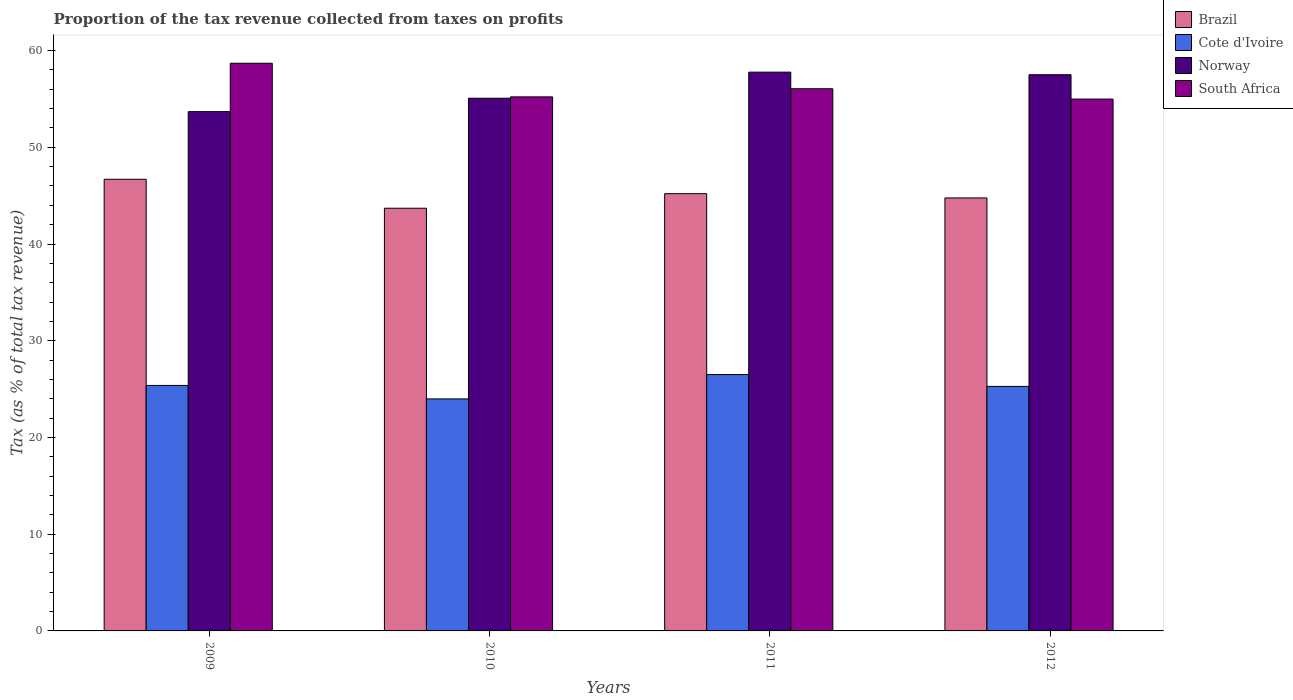How many groups of bars are there?
Provide a short and direct response. 4. Are the number of bars per tick equal to the number of legend labels?
Offer a terse response. Yes. How many bars are there on the 3rd tick from the left?
Offer a very short reply. 4. How many bars are there on the 3rd tick from the right?
Provide a succinct answer. 4. What is the proportion of the tax revenue collected in Norway in 2012?
Offer a terse response. 57.5. Across all years, what is the maximum proportion of the tax revenue collected in Cote d'Ivoire?
Provide a short and direct response. 26.5. Across all years, what is the minimum proportion of the tax revenue collected in Norway?
Ensure brevity in your answer.  53.69. In which year was the proportion of the tax revenue collected in Cote d'Ivoire minimum?
Keep it short and to the point. 2010. What is the total proportion of the tax revenue collected in Norway in the graph?
Give a very brief answer. 224.03. What is the difference between the proportion of the tax revenue collected in South Africa in 2010 and that in 2011?
Make the answer very short. -0.84. What is the difference between the proportion of the tax revenue collected in Brazil in 2010 and the proportion of the tax revenue collected in Norway in 2009?
Your answer should be compact. -9.99. What is the average proportion of the tax revenue collected in Norway per year?
Your response must be concise. 56.01. In the year 2012, what is the difference between the proportion of the tax revenue collected in Brazil and proportion of the tax revenue collected in Cote d'Ivoire?
Offer a terse response. 19.48. In how many years, is the proportion of the tax revenue collected in Brazil greater than 2 %?
Your answer should be compact. 4. What is the ratio of the proportion of the tax revenue collected in Brazil in 2011 to that in 2012?
Your answer should be compact. 1.01. Is the proportion of the tax revenue collected in South Africa in 2010 less than that in 2012?
Offer a very short reply. No. Is the difference between the proportion of the tax revenue collected in Brazil in 2010 and 2012 greater than the difference between the proportion of the tax revenue collected in Cote d'Ivoire in 2010 and 2012?
Give a very brief answer. Yes. What is the difference between the highest and the second highest proportion of the tax revenue collected in South Africa?
Provide a short and direct response. 2.63. What is the difference between the highest and the lowest proportion of the tax revenue collected in South Africa?
Give a very brief answer. 3.7. Is the sum of the proportion of the tax revenue collected in Cote d'Ivoire in 2011 and 2012 greater than the maximum proportion of the tax revenue collected in Brazil across all years?
Make the answer very short. Yes. What does the 2nd bar from the left in 2011 represents?
Offer a terse response. Cote d'Ivoire. What does the 3rd bar from the right in 2012 represents?
Your answer should be very brief. Cote d'Ivoire. Is it the case that in every year, the sum of the proportion of the tax revenue collected in South Africa and proportion of the tax revenue collected in Cote d'Ivoire is greater than the proportion of the tax revenue collected in Norway?
Give a very brief answer. Yes. How many years are there in the graph?
Provide a short and direct response. 4. Does the graph contain any zero values?
Provide a short and direct response. No. What is the title of the graph?
Give a very brief answer. Proportion of the tax revenue collected from taxes on profits. What is the label or title of the X-axis?
Your answer should be compact. Years. What is the label or title of the Y-axis?
Ensure brevity in your answer.  Tax (as % of total tax revenue). What is the Tax (as % of total tax revenue) of Brazil in 2009?
Offer a terse response. 46.69. What is the Tax (as % of total tax revenue) in Cote d'Ivoire in 2009?
Provide a short and direct response. 25.38. What is the Tax (as % of total tax revenue) of Norway in 2009?
Offer a very short reply. 53.69. What is the Tax (as % of total tax revenue) of South Africa in 2009?
Give a very brief answer. 58.69. What is the Tax (as % of total tax revenue) of Brazil in 2010?
Your answer should be very brief. 43.7. What is the Tax (as % of total tax revenue) of Cote d'Ivoire in 2010?
Your answer should be very brief. 23.99. What is the Tax (as % of total tax revenue) in Norway in 2010?
Keep it short and to the point. 55.07. What is the Tax (as % of total tax revenue) of South Africa in 2010?
Give a very brief answer. 55.21. What is the Tax (as % of total tax revenue) in Brazil in 2011?
Offer a very short reply. 45.21. What is the Tax (as % of total tax revenue) in Cote d'Ivoire in 2011?
Give a very brief answer. 26.5. What is the Tax (as % of total tax revenue) in Norway in 2011?
Offer a very short reply. 57.77. What is the Tax (as % of total tax revenue) of South Africa in 2011?
Your answer should be very brief. 56.05. What is the Tax (as % of total tax revenue) of Brazil in 2012?
Your answer should be compact. 44.76. What is the Tax (as % of total tax revenue) of Cote d'Ivoire in 2012?
Offer a terse response. 25.28. What is the Tax (as % of total tax revenue) of Norway in 2012?
Keep it short and to the point. 57.5. What is the Tax (as % of total tax revenue) in South Africa in 2012?
Ensure brevity in your answer.  54.98. Across all years, what is the maximum Tax (as % of total tax revenue) of Brazil?
Offer a terse response. 46.69. Across all years, what is the maximum Tax (as % of total tax revenue) in Cote d'Ivoire?
Your answer should be very brief. 26.5. Across all years, what is the maximum Tax (as % of total tax revenue) in Norway?
Offer a terse response. 57.77. Across all years, what is the maximum Tax (as % of total tax revenue) in South Africa?
Give a very brief answer. 58.69. Across all years, what is the minimum Tax (as % of total tax revenue) of Brazil?
Your answer should be very brief. 43.7. Across all years, what is the minimum Tax (as % of total tax revenue) in Cote d'Ivoire?
Provide a short and direct response. 23.99. Across all years, what is the minimum Tax (as % of total tax revenue) of Norway?
Your answer should be very brief. 53.69. Across all years, what is the minimum Tax (as % of total tax revenue) in South Africa?
Your answer should be compact. 54.98. What is the total Tax (as % of total tax revenue) of Brazil in the graph?
Keep it short and to the point. 180.36. What is the total Tax (as % of total tax revenue) of Cote d'Ivoire in the graph?
Your answer should be compact. 101.15. What is the total Tax (as % of total tax revenue) of Norway in the graph?
Your answer should be very brief. 224.03. What is the total Tax (as % of total tax revenue) in South Africa in the graph?
Ensure brevity in your answer.  224.94. What is the difference between the Tax (as % of total tax revenue) in Brazil in 2009 and that in 2010?
Make the answer very short. 2.99. What is the difference between the Tax (as % of total tax revenue) of Cote d'Ivoire in 2009 and that in 2010?
Give a very brief answer. 1.39. What is the difference between the Tax (as % of total tax revenue) of Norway in 2009 and that in 2010?
Make the answer very short. -1.39. What is the difference between the Tax (as % of total tax revenue) of South Africa in 2009 and that in 2010?
Keep it short and to the point. 3.47. What is the difference between the Tax (as % of total tax revenue) in Brazil in 2009 and that in 2011?
Your response must be concise. 1.49. What is the difference between the Tax (as % of total tax revenue) of Cote d'Ivoire in 2009 and that in 2011?
Offer a very short reply. -1.12. What is the difference between the Tax (as % of total tax revenue) of Norway in 2009 and that in 2011?
Your answer should be very brief. -4.08. What is the difference between the Tax (as % of total tax revenue) in South Africa in 2009 and that in 2011?
Your response must be concise. 2.63. What is the difference between the Tax (as % of total tax revenue) in Brazil in 2009 and that in 2012?
Ensure brevity in your answer.  1.93. What is the difference between the Tax (as % of total tax revenue) in Cote d'Ivoire in 2009 and that in 2012?
Offer a terse response. 0.1. What is the difference between the Tax (as % of total tax revenue) in Norway in 2009 and that in 2012?
Your response must be concise. -3.82. What is the difference between the Tax (as % of total tax revenue) of South Africa in 2009 and that in 2012?
Offer a terse response. 3.7. What is the difference between the Tax (as % of total tax revenue) in Brazil in 2010 and that in 2011?
Offer a terse response. -1.51. What is the difference between the Tax (as % of total tax revenue) of Cote d'Ivoire in 2010 and that in 2011?
Ensure brevity in your answer.  -2.52. What is the difference between the Tax (as % of total tax revenue) of Norway in 2010 and that in 2011?
Offer a very short reply. -2.7. What is the difference between the Tax (as % of total tax revenue) of South Africa in 2010 and that in 2011?
Give a very brief answer. -0.84. What is the difference between the Tax (as % of total tax revenue) in Brazil in 2010 and that in 2012?
Offer a very short reply. -1.06. What is the difference between the Tax (as % of total tax revenue) in Cote d'Ivoire in 2010 and that in 2012?
Keep it short and to the point. -1.29. What is the difference between the Tax (as % of total tax revenue) in Norway in 2010 and that in 2012?
Provide a short and direct response. -2.43. What is the difference between the Tax (as % of total tax revenue) of South Africa in 2010 and that in 2012?
Make the answer very short. 0.23. What is the difference between the Tax (as % of total tax revenue) of Brazil in 2011 and that in 2012?
Offer a terse response. 0.44. What is the difference between the Tax (as % of total tax revenue) of Cote d'Ivoire in 2011 and that in 2012?
Keep it short and to the point. 1.23. What is the difference between the Tax (as % of total tax revenue) in Norway in 2011 and that in 2012?
Your answer should be very brief. 0.27. What is the difference between the Tax (as % of total tax revenue) of South Africa in 2011 and that in 2012?
Offer a very short reply. 1.07. What is the difference between the Tax (as % of total tax revenue) in Brazil in 2009 and the Tax (as % of total tax revenue) in Cote d'Ivoire in 2010?
Provide a short and direct response. 22.71. What is the difference between the Tax (as % of total tax revenue) of Brazil in 2009 and the Tax (as % of total tax revenue) of Norway in 2010?
Your answer should be compact. -8.38. What is the difference between the Tax (as % of total tax revenue) of Brazil in 2009 and the Tax (as % of total tax revenue) of South Africa in 2010?
Provide a succinct answer. -8.52. What is the difference between the Tax (as % of total tax revenue) of Cote d'Ivoire in 2009 and the Tax (as % of total tax revenue) of Norway in 2010?
Ensure brevity in your answer.  -29.69. What is the difference between the Tax (as % of total tax revenue) of Cote d'Ivoire in 2009 and the Tax (as % of total tax revenue) of South Africa in 2010?
Provide a short and direct response. -29.83. What is the difference between the Tax (as % of total tax revenue) in Norway in 2009 and the Tax (as % of total tax revenue) in South Africa in 2010?
Your answer should be compact. -1.53. What is the difference between the Tax (as % of total tax revenue) in Brazil in 2009 and the Tax (as % of total tax revenue) in Cote d'Ivoire in 2011?
Offer a very short reply. 20.19. What is the difference between the Tax (as % of total tax revenue) in Brazil in 2009 and the Tax (as % of total tax revenue) in Norway in 2011?
Ensure brevity in your answer.  -11.07. What is the difference between the Tax (as % of total tax revenue) in Brazil in 2009 and the Tax (as % of total tax revenue) in South Africa in 2011?
Make the answer very short. -9.36. What is the difference between the Tax (as % of total tax revenue) in Cote d'Ivoire in 2009 and the Tax (as % of total tax revenue) in Norway in 2011?
Give a very brief answer. -32.39. What is the difference between the Tax (as % of total tax revenue) in Cote d'Ivoire in 2009 and the Tax (as % of total tax revenue) in South Africa in 2011?
Provide a short and direct response. -30.67. What is the difference between the Tax (as % of total tax revenue) in Norway in 2009 and the Tax (as % of total tax revenue) in South Africa in 2011?
Give a very brief answer. -2.37. What is the difference between the Tax (as % of total tax revenue) in Brazil in 2009 and the Tax (as % of total tax revenue) in Cote d'Ivoire in 2012?
Keep it short and to the point. 21.42. What is the difference between the Tax (as % of total tax revenue) in Brazil in 2009 and the Tax (as % of total tax revenue) in Norway in 2012?
Your answer should be very brief. -10.81. What is the difference between the Tax (as % of total tax revenue) of Brazil in 2009 and the Tax (as % of total tax revenue) of South Africa in 2012?
Offer a very short reply. -8.29. What is the difference between the Tax (as % of total tax revenue) in Cote d'Ivoire in 2009 and the Tax (as % of total tax revenue) in Norway in 2012?
Make the answer very short. -32.12. What is the difference between the Tax (as % of total tax revenue) in Cote d'Ivoire in 2009 and the Tax (as % of total tax revenue) in South Africa in 2012?
Offer a very short reply. -29.61. What is the difference between the Tax (as % of total tax revenue) in Norway in 2009 and the Tax (as % of total tax revenue) in South Africa in 2012?
Offer a very short reply. -1.3. What is the difference between the Tax (as % of total tax revenue) of Brazil in 2010 and the Tax (as % of total tax revenue) of Cote d'Ivoire in 2011?
Provide a succinct answer. 17.2. What is the difference between the Tax (as % of total tax revenue) in Brazil in 2010 and the Tax (as % of total tax revenue) in Norway in 2011?
Give a very brief answer. -14.07. What is the difference between the Tax (as % of total tax revenue) of Brazil in 2010 and the Tax (as % of total tax revenue) of South Africa in 2011?
Provide a short and direct response. -12.35. What is the difference between the Tax (as % of total tax revenue) in Cote d'Ivoire in 2010 and the Tax (as % of total tax revenue) in Norway in 2011?
Provide a succinct answer. -33.78. What is the difference between the Tax (as % of total tax revenue) in Cote d'Ivoire in 2010 and the Tax (as % of total tax revenue) in South Africa in 2011?
Provide a succinct answer. -32.07. What is the difference between the Tax (as % of total tax revenue) in Norway in 2010 and the Tax (as % of total tax revenue) in South Africa in 2011?
Your response must be concise. -0.98. What is the difference between the Tax (as % of total tax revenue) of Brazil in 2010 and the Tax (as % of total tax revenue) of Cote d'Ivoire in 2012?
Offer a very short reply. 18.42. What is the difference between the Tax (as % of total tax revenue) of Brazil in 2010 and the Tax (as % of total tax revenue) of Norway in 2012?
Offer a very short reply. -13.8. What is the difference between the Tax (as % of total tax revenue) in Brazil in 2010 and the Tax (as % of total tax revenue) in South Africa in 2012?
Make the answer very short. -11.28. What is the difference between the Tax (as % of total tax revenue) in Cote d'Ivoire in 2010 and the Tax (as % of total tax revenue) in Norway in 2012?
Offer a terse response. -33.52. What is the difference between the Tax (as % of total tax revenue) in Cote d'Ivoire in 2010 and the Tax (as % of total tax revenue) in South Africa in 2012?
Make the answer very short. -31. What is the difference between the Tax (as % of total tax revenue) in Norway in 2010 and the Tax (as % of total tax revenue) in South Africa in 2012?
Keep it short and to the point. 0.09. What is the difference between the Tax (as % of total tax revenue) of Brazil in 2011 and the Tax (as % of total tax revenue) of Cote d'Ivoire in 2012?
Ensure brevity in your answer.  19.93. What is the difference between the Tax (as % of total tax revenue) of Brazil in 2011 and the Tax (as % of total tax revenue) of Norway in 2012?
Make the answer very short. -12.3. What is the difference between the Tax (as % of total tax revenue) of Brazil in 2011 and the Tax (as % of total tax revenue) of South Africa in 2012?
Ensure brevity in your answer.  -9.78. What is the difference between the Tax (as % of total tax revenue) of Cote d'Ivoire in 2011 and the Tax (as % of total tax revenue) of Norway in 2012?
Your answer should be very brief. -31. What is the difference between the Tax (as % of total tax revenue) in Cote d'Ivoire in 2011 and the Tax (as % of total tax revenue) in South Africa in 2012?
Offer a terse response. -28.48. What is the difference between the Tax (as % of total tax revenue) in Norway in 2011 and the Tax (as % of total tax revenue) in South Africa in 2012?
Keep it short and to the point. 2.78. What is the average Tax (as % of total tax revenue) in Brazil per year?
Your answer should be compact. 45.09. What is the average Tax (as % of total tax revenue) in Cote d'Ivoire per year?
Provide a succinct answer. 25.29. What is the average Tax (as % of total tax revenue) in Norway per year?
Your answer should be compact. 56.01. What is the average Tax (as % of total tax revenue) in South Africa per year?
Your answer should be compact. 56.23. In the year 2009, what is the difference between the Tax (as % of total tax revenue) in Brazil and Tax (as % of total tax revenue) in Cote d'Ivoire?
Ensure brevity in your answer.  21.31. In the year 2009, what is the difference between the Tax (as % of total tax revenue) of Brazil and Tax (as % of total tax revenue) of Norway?
Your answer should be compact. -6.99. In the year 2009, what is the difference between the Tax (as % of total tax revenue) of Brazil and Tax (as % of total tax revenue) of South Africa?
Provide a short and direct response. -11.99. In the year 2009, what is the difference between the Tax (as % of total tax revenue) in Cote d'Ivoire and Tax (as % of total tax revenue) in Norway?
Offer a terse response. -28.31. In the year 2009, what is the difference between the Tax (as % of total tax revenue) of Cote d'Ivoire and Tax (as % of total tax revenue) of South Africa?
Ensure brevity in your answer.  -33.31. In the year 2009, what is the difference between the Tax (as % of total tax revenue) in Norway and Tax (as % of total tax revenue) in South Africa?
Provide a short and direct response. -5. In the year 2010, what is the difference between the Tax (as % of total tax revenue) in Brazil and Tax (as % of total tax revenue) in Cote d'Ivoire?
Keep it short and to the point. 19.71. In the year 2010, what is the difference between the Tax (as % of total tax revenue) in Brazil and Tax (as % of total tax revenue) in Norway?
Give a very brief answer. -11.37. In the year 2010, what is the difference between the Tax (as % of total tax revenue) in Brazil and Tax (as % of total tax revenue) in South Africa?
Ensure brevity in your answer.  -11.51. In the year 2010, what is the difference between the Tax (as % of total tax revenue) of Cote d'Ivoire and Tax (as % of total tax revenue) of Norway?
Your answer should be compact. -31.09. In the year 2010, what is the difference between the Tax (as % of total tax revenue) in Cote d'Ivoire and Tax (as % of total tax revenue) in South Africa?
Provide a short and direct response. -31.23. In the year 2010, what is the difference between the Tax (as % of total tax revenue) in Norway and Tax (as % of total tax revenue) in South Africa?
Your answer should be compact. -0.14. In the year 2011, what is the difference between the Tax (as % of total tax revenue) of Brazil and Tax (as % of total tax revenue) of Cote d'Ivoire?
Make the answer very short. 18.7. In the year 2011, what is the difference between the Tax (as % of total tax revenue) in Brazil and Tax (as % of total tax revenue) in Norway?
Your response must be concise. -12.56. In the year 2011, what is the difference between the Tax (as % of total tax revenue) of Brazil and Tax (as % of total tax revenue) of South Africa?
Offer a terse response. -10.85. In the year 2011, what is the difference between the Tax (as % of total tax revenue) in Cote d'Ivoire and Tax (as % of total tax revenue) in Norway?
Ensure brevity in your answer.  -31.26. In the year 2011, what is the difference between the Tax (as % of total tax revenue) in Cote d'Ivoire and Tax (as % of total tax revenue) in South Africa?
Offer a terse response. -29.55. In the year 2011, what is the difference between the Tax (as % of total tax revenue) of Norway and Tax (as % of total tax revenue) of South Africa?
Provide a short and direct response. 1.72. In the year 2012, what is the difference between the Tax (as % of total tax revenue) in Brazil and Tax (as % of total tax revenue) in Cote d'Ivoire?
Your answer should be compact. 19.48. In the year 2012, what is the difference between the Tax (as % of total tax revenue) in Brazil and Tax (as % of total tax revenue) in Norway?
Offer a very short reply. -12.74. In the year 2012, what is the difference between the Tax (as % of total tax revenue) of Brazil and Tax (as % of total tax revenue) of South Africa?
Provide a succinct answer. -10.22. In the year 2012, what is the difference between the Tax (as % of total tax revenue) in Cote d'Ivoire and Tax (as % of total tax revenue) in Norway?
Give a very brief answer. -32.22. In the year 2012, what is the difference between the Tax (as % of total tax revenue) of Cote d'Ivoire and Tax (as % of total tax revenue) of South Africa?
Provide a short and direct response. -29.71. In the year 2012, what is the difference between the Tax (as % of total tax revenue) of Norway and Tax (as % of total tax revenue) of South Africa?
Your answer should be compact. 2.52. What is the ratio of the Tax (as % of total tax revenue) in Brazil in 2009 to that in 2010?
Offer a very short reply. 1.07. What is the ratio of the Tax (as % of total tax revenue) of Cote d'Ivoire in 2009 to that in 2010?
Give a very brief answer. 1.06. What is the ratio of the Tax (as % of total tax revenue) of Norway in 2009 to that in 2010?
Give a very brief answer. 0.97. What is the ratio of the Tax (as % of total tax revenue) in South Africa in 2009 to that in 2010?
Your response must be concise. 1.06. What is the ratio of the Tax (as % of total tax revenue) in Brazil in 2009 to that in 2011?
Provide a succinct answer. 1.03. What is the ratio of the Tax (as % of total tax revenue) of Cote d'Ivoire in 2009 to that in 2011?
Offer a terse response. 0.96. What is the ratio of the Tax (as % of total tax revenue) of Norway in 2009 to that in 2011?
Give a very brief answer. 0.93. What is the ratio of the Tax (as % of total tax revenue) of South Africa in 2009 to that in 2011?
Keep it short and to the point. 1.05. What is the ratio of the Tax (as % of total tax revenue) of Brazil in 2009 to that in 2012?
Give a very brief answer. 1.04. What is the ratio of the Tax (as % of total tax revenue) in Cote d'Ivoire in 2009 to that in 2012?
Provide a short and direct response. 1. What is the ratio of the Tax (as % of total tax revenue) of Norway in 2009 to that in 2012?
Provide a succinct answer. 0.93. What is the ratio of the Tax (as % of total tax revenue) of South Africa in 2009 to that in 2012?
Make the answer very short. 1.07. What is the ratio of the Tax (as % of total tax revenue) in Brazil in 2010 to that in 2011?
Offer a very short reply. 0.97. What is the ratio of the Tax (as % of total tax revenue) of Cote d'Ivoire in 2010 to that in 2011?
Your response must be concise. 0.91. What is the ratio of the Tax (as % of total tax revenue) of Norway in 2010 to that in 2011?
Ensure brevity in your answer.  0.95. What is the ratio of the Tax (as % of total tax revenue) in Brazil in 2010 to that in 2012?
Provide a short and direct response. 0.98. What is the ratio of the Tax (as % of total tax revenue) of Cote d'Ivoire in 2010 to that in 2012?
Provide a succinct answer. 0.95. What is the ratio of the Tax (as % of total tax revenue) in Norway in 2010 to that in 2012?
Your response must be concise. 0.96. What is the ratio of the Tax (as % of total tax revenue) in South Africa in 2010 to that in 2012?
Provide a succinct answer. 1. What is the ratio of the Tax (as % of total tax revenue) of Brazil in 2011 to that in 2012?
Give a very brief answer. 1.01. What is the ratio of the Tax (as % of total tax revenue) in Cote d'Ivoire in 2011 to that in 2012?
Provide a short and direct response. 1.05. What is the ratio of the Tax (as % of total tax revenue) in South Africa in 2011 to that in 2012?
Offer a very short reply. 1.02. What is the difference between the highest and the second highest Tax (as % of total tax revenue) of Brazil?
Provide a succinct answer. 1.49. What is the difference between the highest and the second highest Tax (as % of total tax revenue) in Cote d'Ivoire?
Give a very brief answer. 1.12. What is the difference between the highest and the second highest Tax (as % of total tax revenue) in Norway?
Provide a succinct answer. 0.27. What is the difference between the highest and the second highest Tax (as % of total tax revenue) of South Africa?
Your response must be concise. 2.63. What is the difference between the highest and the lowest Tax (as % of total tax revenue) in Brazil?
Your response must be concise. 2.99. What is the difference between the highest and the lowest Tax (as % of total tax revenue) in Cote d'Ivoire?
Keep it short and to the point. 2.52. What is the difference between the highest and the lowest Tax (as % of total tax revenue) in Norway?
Provide a short and direct response. 4.08. What is the difference between the highest and the lowest Tax (as % of total tax revenue) in South Africa?
Make the answer very short. 3.7. 